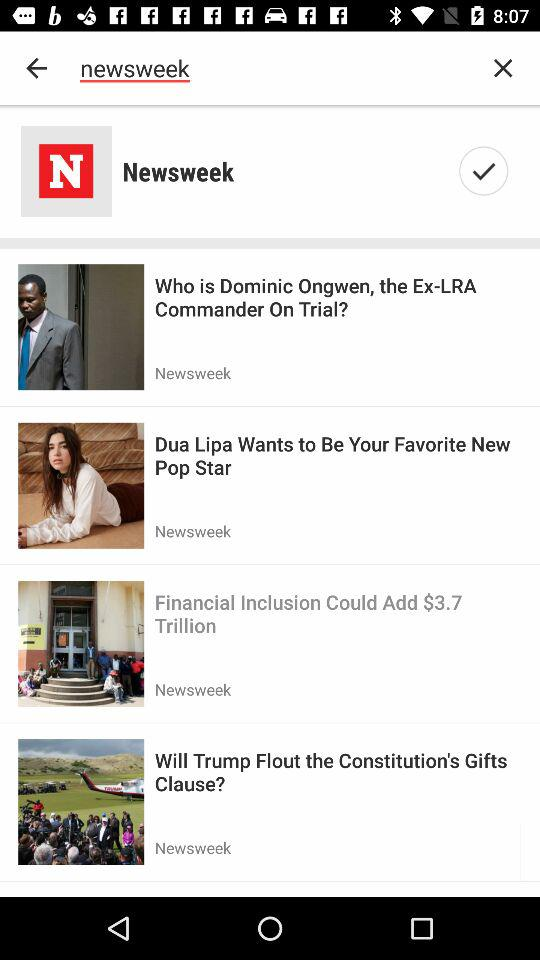What news is listed in the "Newsweek" tab? The news listed under the "Newsweek" tab are "Who is Dominic Ongwen, the Ex-LRA Commander On Trial?", "Dua Lipa Wants to Be Your Favorite New Pop Star", "Financial Inclusion Could Add $3.7 Trillion" and "Will Trump Flout the Constitution's Gifts Clause?". 